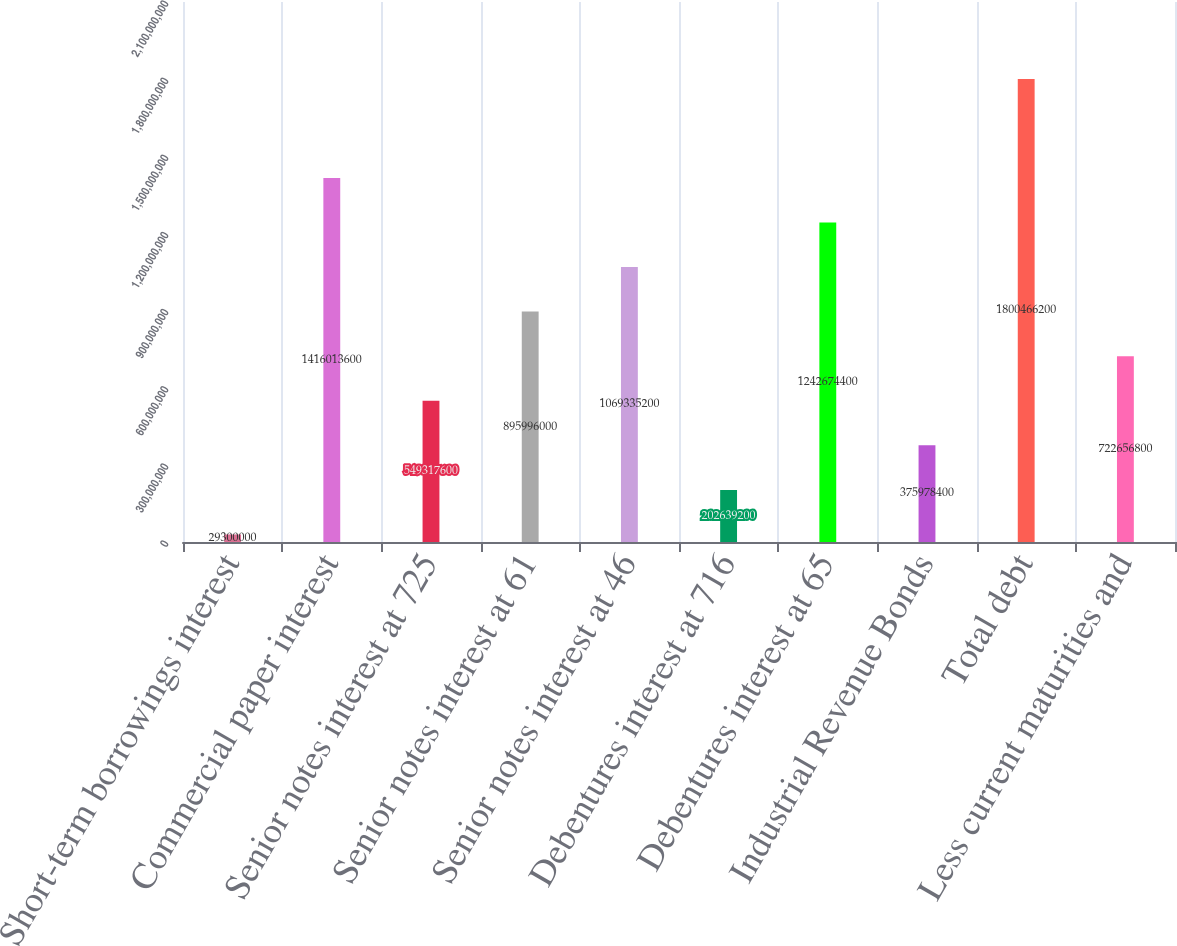<chart> <loc_0><loc_0><loc_500><loc_500><bar_chart><fcel>Short-term borrowings interest<fcel>Commercial paper interest<fcel>Senior notes interest at 725<fcel>Senior notes interest at 61<fcel>Senior notes interest at 46<fcel>Debentures interest at 716<fcel>Debentures interest at 65<fcel>Industrial Revenue Bonds<fcel>Total debt<fcel>Less current maturities and<nl><fcel>2.93e+07<fcel>1.41601e+09<fcel>5.49318e+08<fcel>8.95996e+08<fcel>1.06934e+09<fcel>2.02639e+08<fcel>1.24267e+09<fcel>3.75978e+08<fcel>1.80047e+09<fcel>7.22657e+08<nl></chart> 